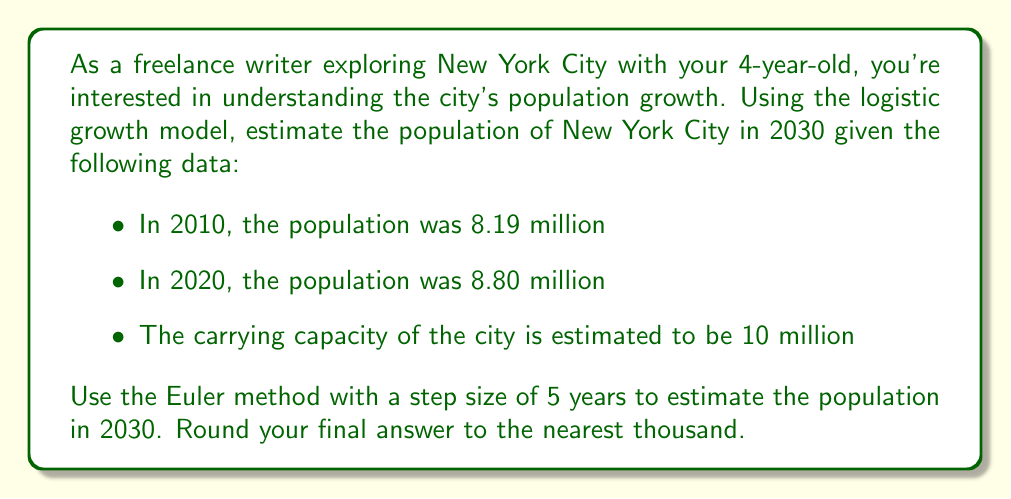Can you solve this math problem? Let's approach this step-by-step using the logistic growth model and Euler method:

1) The logistic growth model is given by the differential equation:

   $$\frac{dP}{dt} = rP(1 - \frac{P}{K})$$

   where $P$ is the population, $t$ is time, $r$ is the growth rate, and $K$ is the carrying capacity.

2) We need to find $r$ using the given data. We can use the population values from 2010 and 2020:

   $$8.80 = 8.19 + 10 \cdot r \cdot 8.19 \cdot (1 - \frac{8.19}{10})$$

   Solving this equation, we get $r \approx 0.0816$.

3) Now we can use the Euler method to estimate the population in 2030. The Euler method is given by:

   $$P_{n+1} = P_n + h \cdot f(t_n, P_n)$$

   where $h$ is the step size (5 years in this case), and $f(t, P) = rP(1 - \frac{P}{K})$.

4) Let's calculate for 2025 first:

   $$P_{2025} = 8.80 + 5 \cdot 0.0816 \cdot 8.80 \cdot (1 - \frac{8.80}{10}) = 9.27$$

5) Now for 2030:

   $$P_{2030} = 9.27 + 5 \cdot 0.0816 \cdot 9.27 \cdot (1 - \frac{9.27}{10}) = 9.62$$

6) Rounding to the nearest thousand, we get 9,620,000.
Answer: 9,620,000 